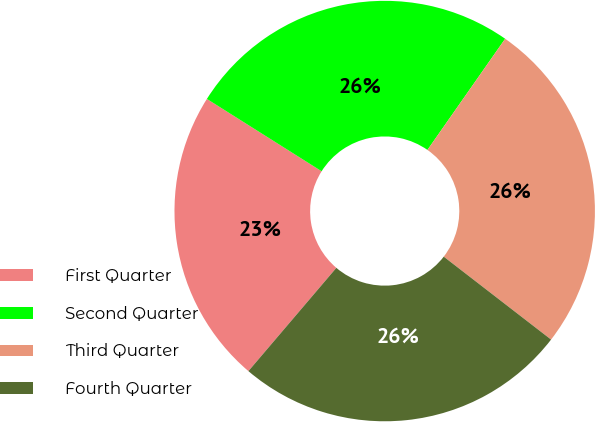Convert chart to OTSL. <chart><loc_0><loc_0><loc_500><loc_500><pie_chart><fcel>First Quarter<fcel>Second Quarter<fcel>Third Quarter<fcel>Fourth Quarter<nl><fcel>22.73%<fcel>25.76%<fcel>25.76%<fcel>25.76%<nl></chart> 